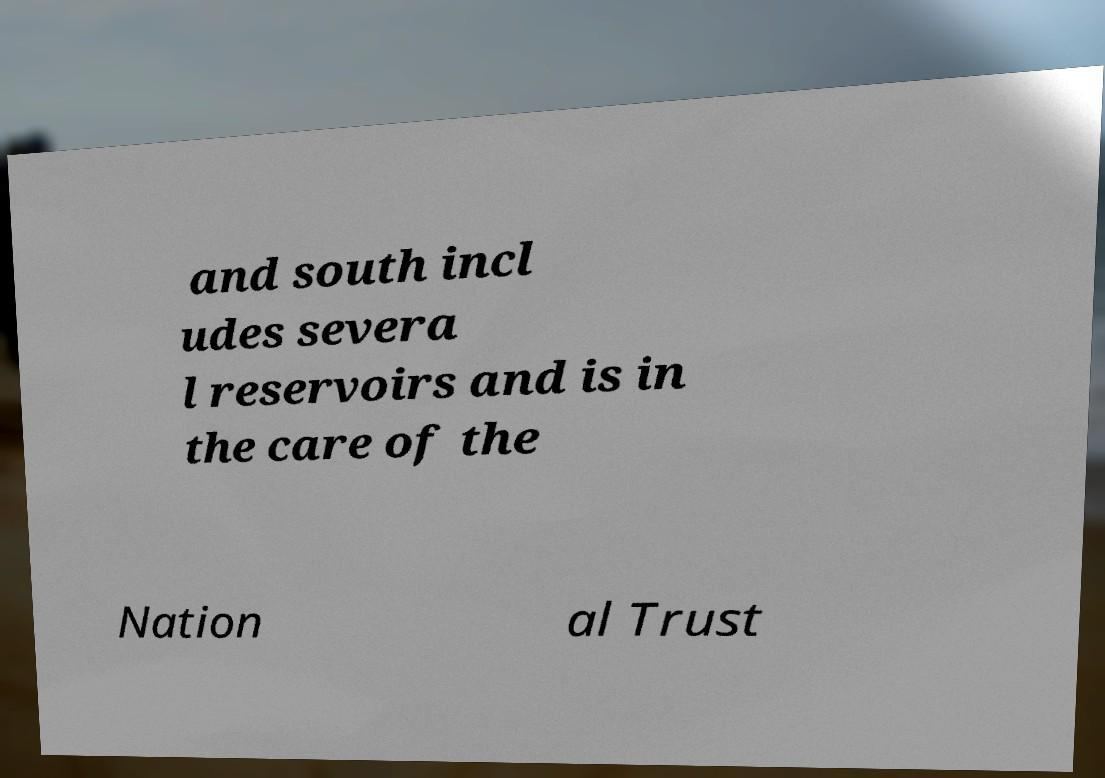There's text embedded in this image that I need extracted. Can you transcribe it verbatim? and south incl udes severa l reservoirs and is in the care of the Nation al Trust 